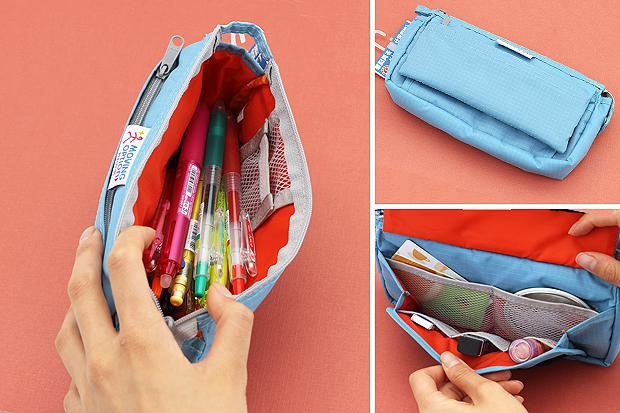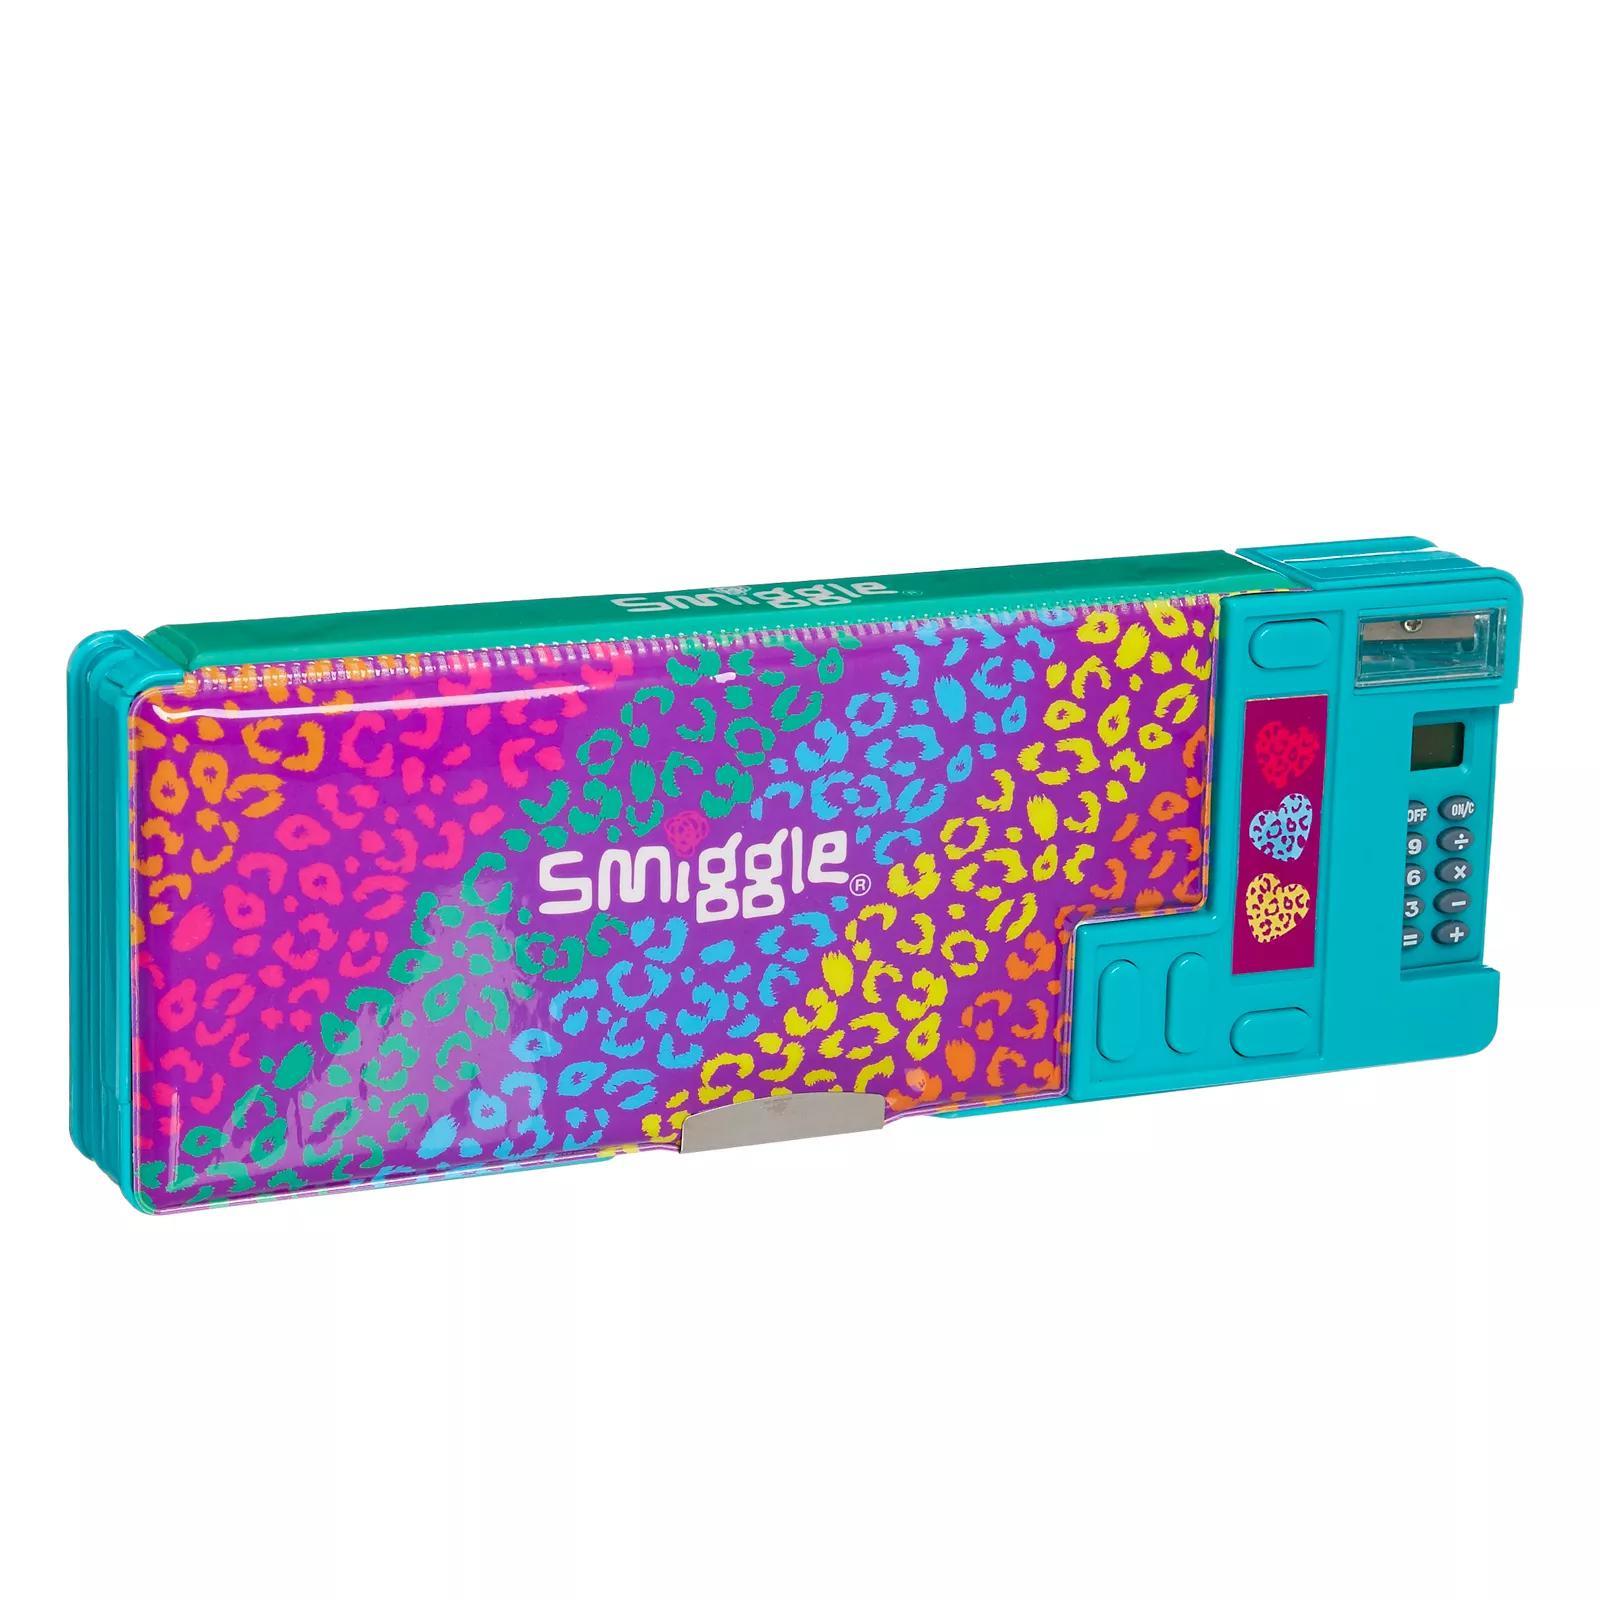The first image is the image on the left, the second image is the image on the right. Evaluate the accuracy of this statement regarding the images: "An image collage shows a pencil case that opens clam-shell style, along with the same type case closed.". Is it true? Answer yes or no. No. The first image is the image on the left, the second image is the image on the right. Examine the images to the left and right. Is the description "At least of the images shows only one pencil pouch." accurate? Answer yes or no. Yes. 